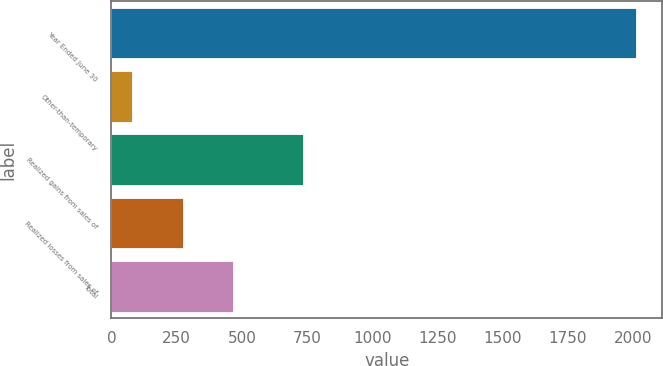Convert chart. <chart><loc_0><loc_0><loc_500><loc_500><bar_chart><fcel>Year Ended June 30<fcel>Other-than-temporary<fcel>Realized gains from sales of<fcel>Realized losses from sales of<fcel>Total<nl><fcel>2011<fcel>80<fcel>734<fcel>273.1<fcel>466.2<nl></chart> 